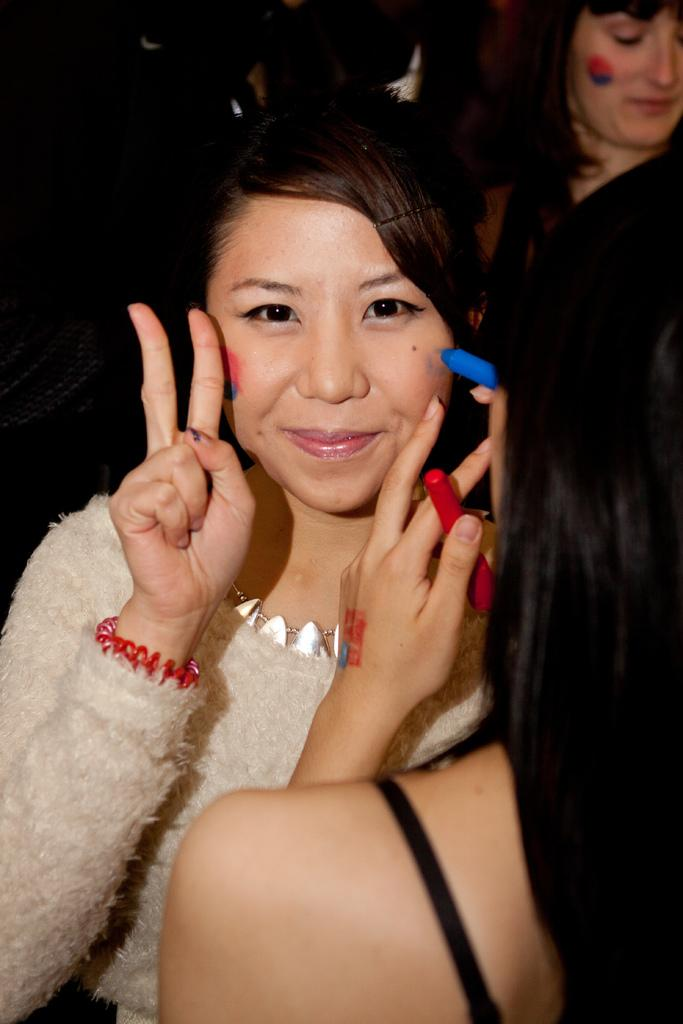Who is the main subject in the image? There is a woman in the image. What is the woman doing in the image? The woman is smiling and gesturing with two fingers. Are there any other people in the image? Yes, there are two other women standing around the first woman. What type of cheese is being used to create the vase in the image? There is no vase or cheese present in the image. 